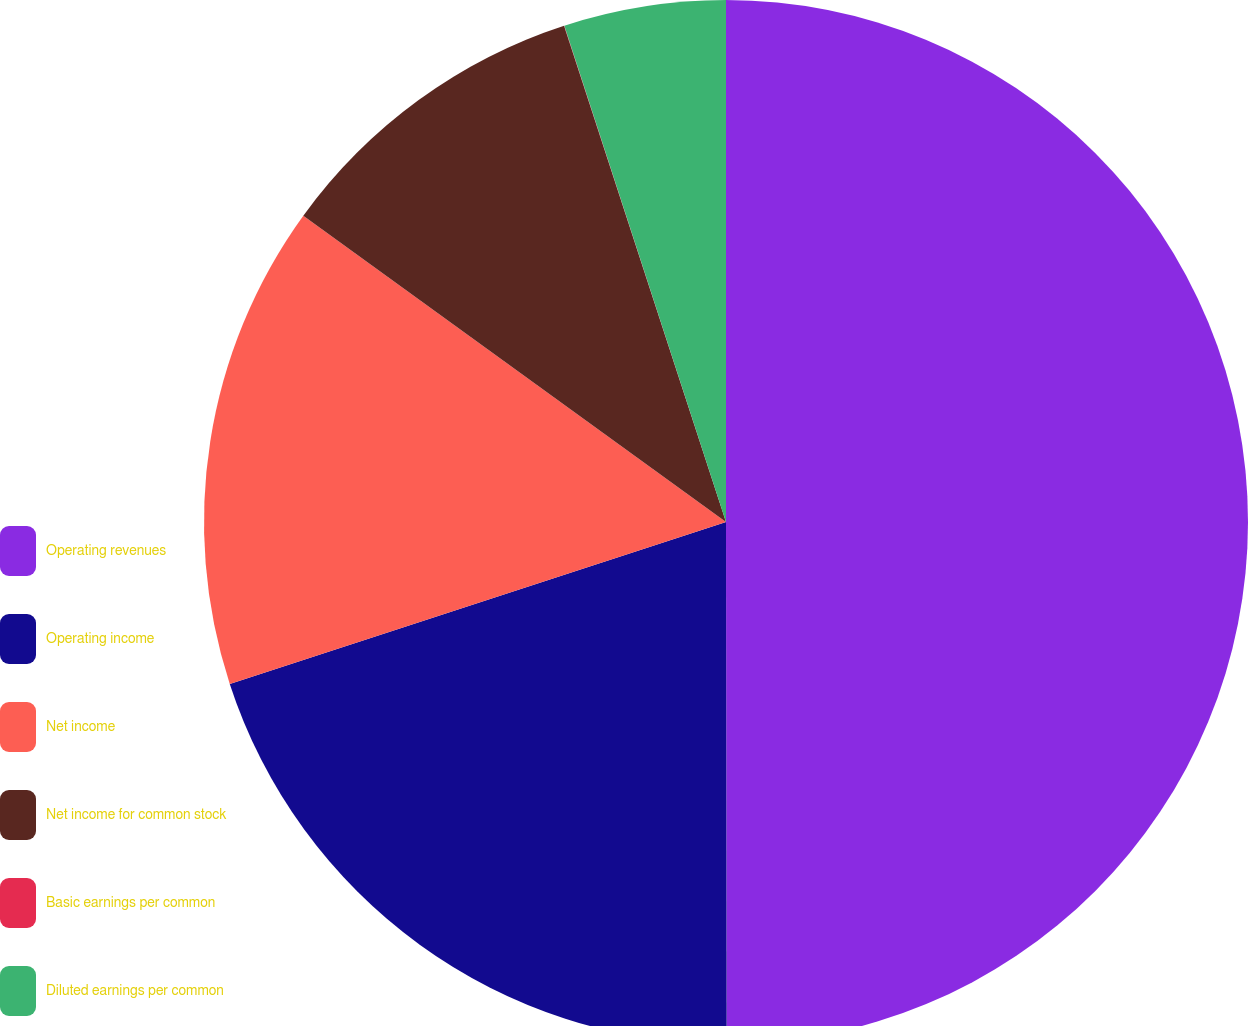<chart> <loc_0><loc_0><loc_500><loc_500><pie_chart><fcel>Operating revenues<fcel>Operating income<fcel>Net income<fcel>Net income for common stock<fcel>Basic earnings per common<fcel>Diluted earnings per common<nl><fcel>49.98%<fcel>20.0%<fcel>15.0%<fcel>10.0%<fcel>0.01%<fcel>5.01%<nl></chart> 